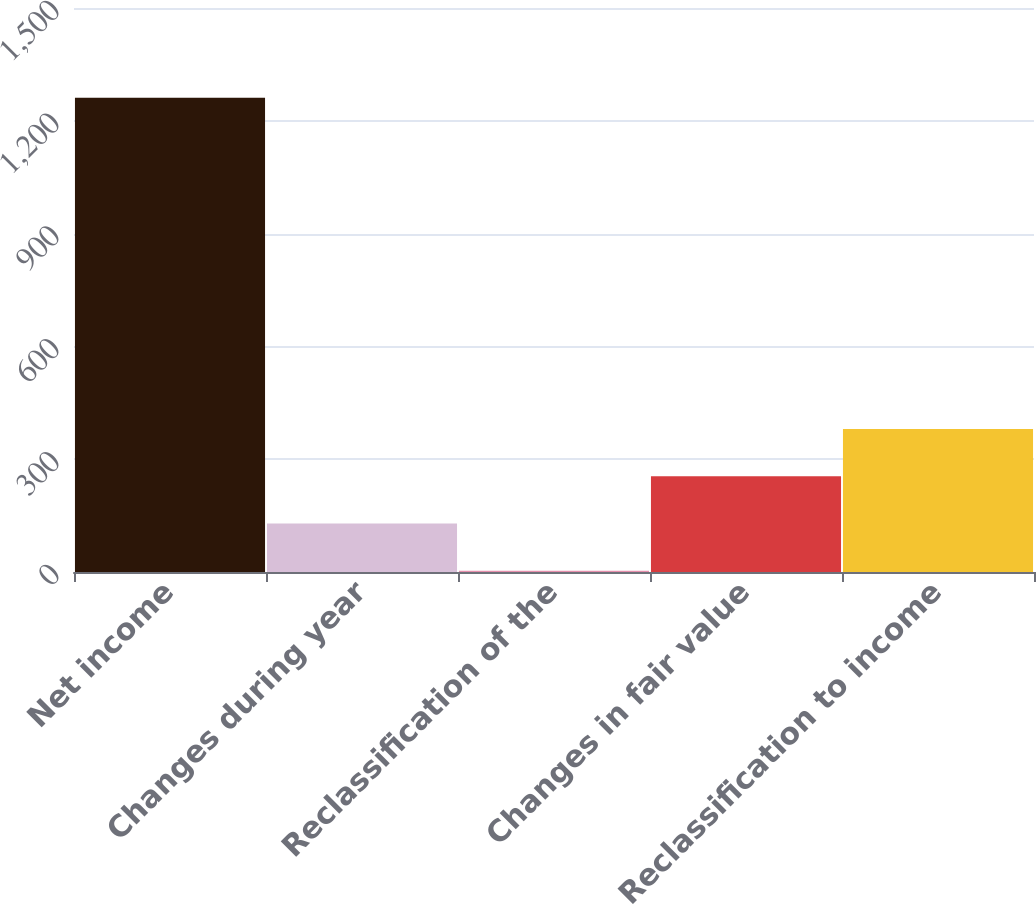Convert chart to OTSL. <chart><loc_0><loc_0><loc_500><loc_500><bar_chart><fcel>Net income<fcel>Changes during year<fcel>Reclassification of the<fcel>Changes in fair value<fcel>Reclassification to income<nl><fcel>1261<fcel>128.8<fcel>3<fcel>254.6<fcel>380.4<nl></chart> 